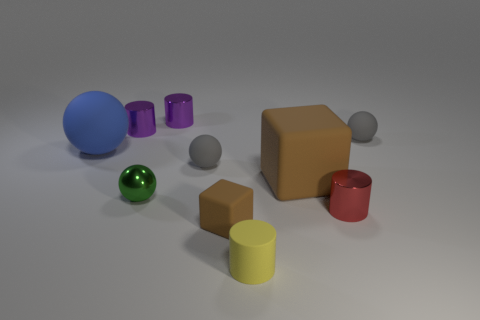Subtract all cylinders. How many objects are left? 6 Subtract all brown blocks. Subtract all big blue spheres. How many objects are left? 7 Add 1 big blue things. How many big blue things are left? 2 Add 2 yellow rubber objects. How many yellow rubber objects exist? 3 Subtract 0 brown balls. How many objects are left? 10 